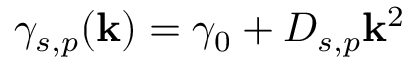<formula> <loc_0><loc_0><loc_500><loc_500>\gamma _ { s , p } ( k ) = \gamma _ { 0 } + D _ { s , p } k ^ { 2 }</formula> 